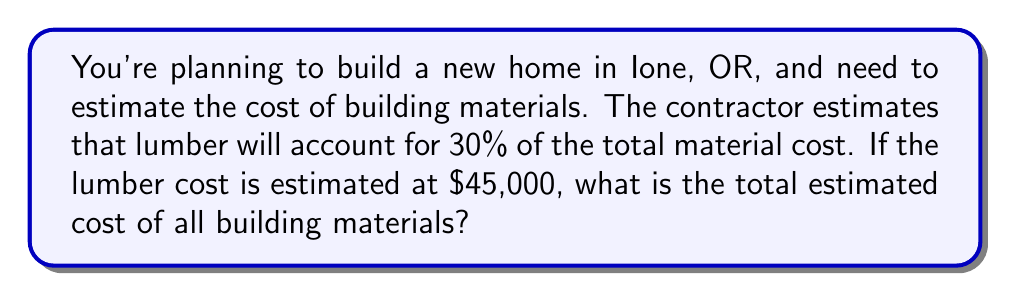Provide a solution to this math problem. To solve this problem, we need to use percentages and their relationship to the whole. Let's break it down step-by-step:

1. We know that lumber accounts for 30% of the total material cost.
2. We're given that the lumber cost is $45,000.

Let's set up an equation:
$45,000 = 30\% \times \text{Total Cost}$

To solve for the total cost, we need to divide both sides by 30%:

$\frac{45,000}{30\%} = \text{Total Cost}$

To calculate this:

1. Convert 30% to a decimal: $30\% = 0.30$
2. Divide $45,000 by 0.30:

$$\text{Total Cost} = \frac{45,000}{0.30} = 150,000$$

Therefore, the total estimated cost of all building materials is $150,000.

We can verify this:
$30\% \text{ of } 150,000 = 0.30 \times 150,000 = 45,000$

This confirms our original lumber cost, so our calculation is correct.
Answer: $150,000 